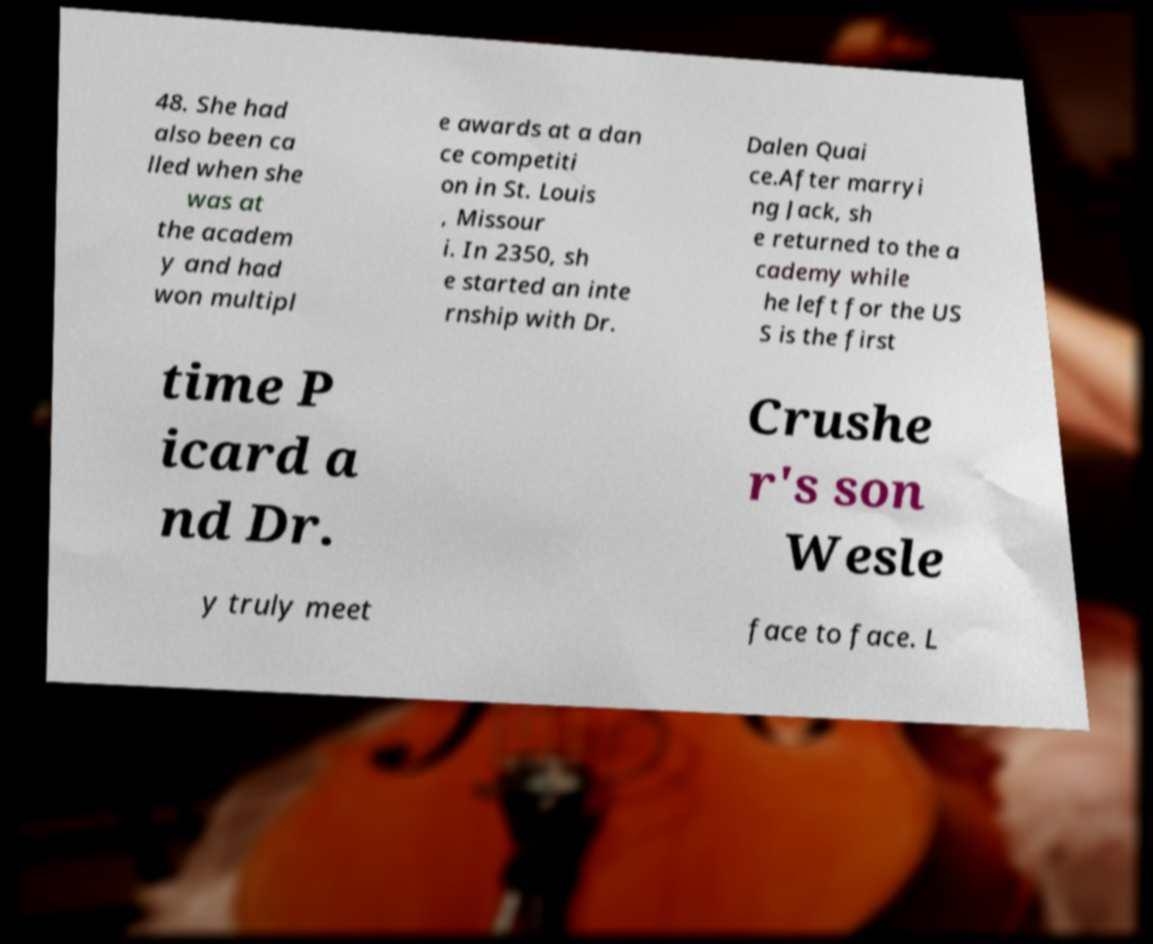Can you read and provide the text displayed in the image?This photo seems to have some interesting text. Can you extract and type it out for me? 48. She had also been ca lled when she was at the academ y and had won multipl e awards at a dan ce competiti on in St. Louis , Missour i. In 2350, sh e started an inte rnship with Dr. Dalen Quai ce.After marryi ng Jack, sh e returned to the a cademy while he left for the US S is the first time P icard a nd Dr. Crushe r's son Wesle y truly meet face to face. L 